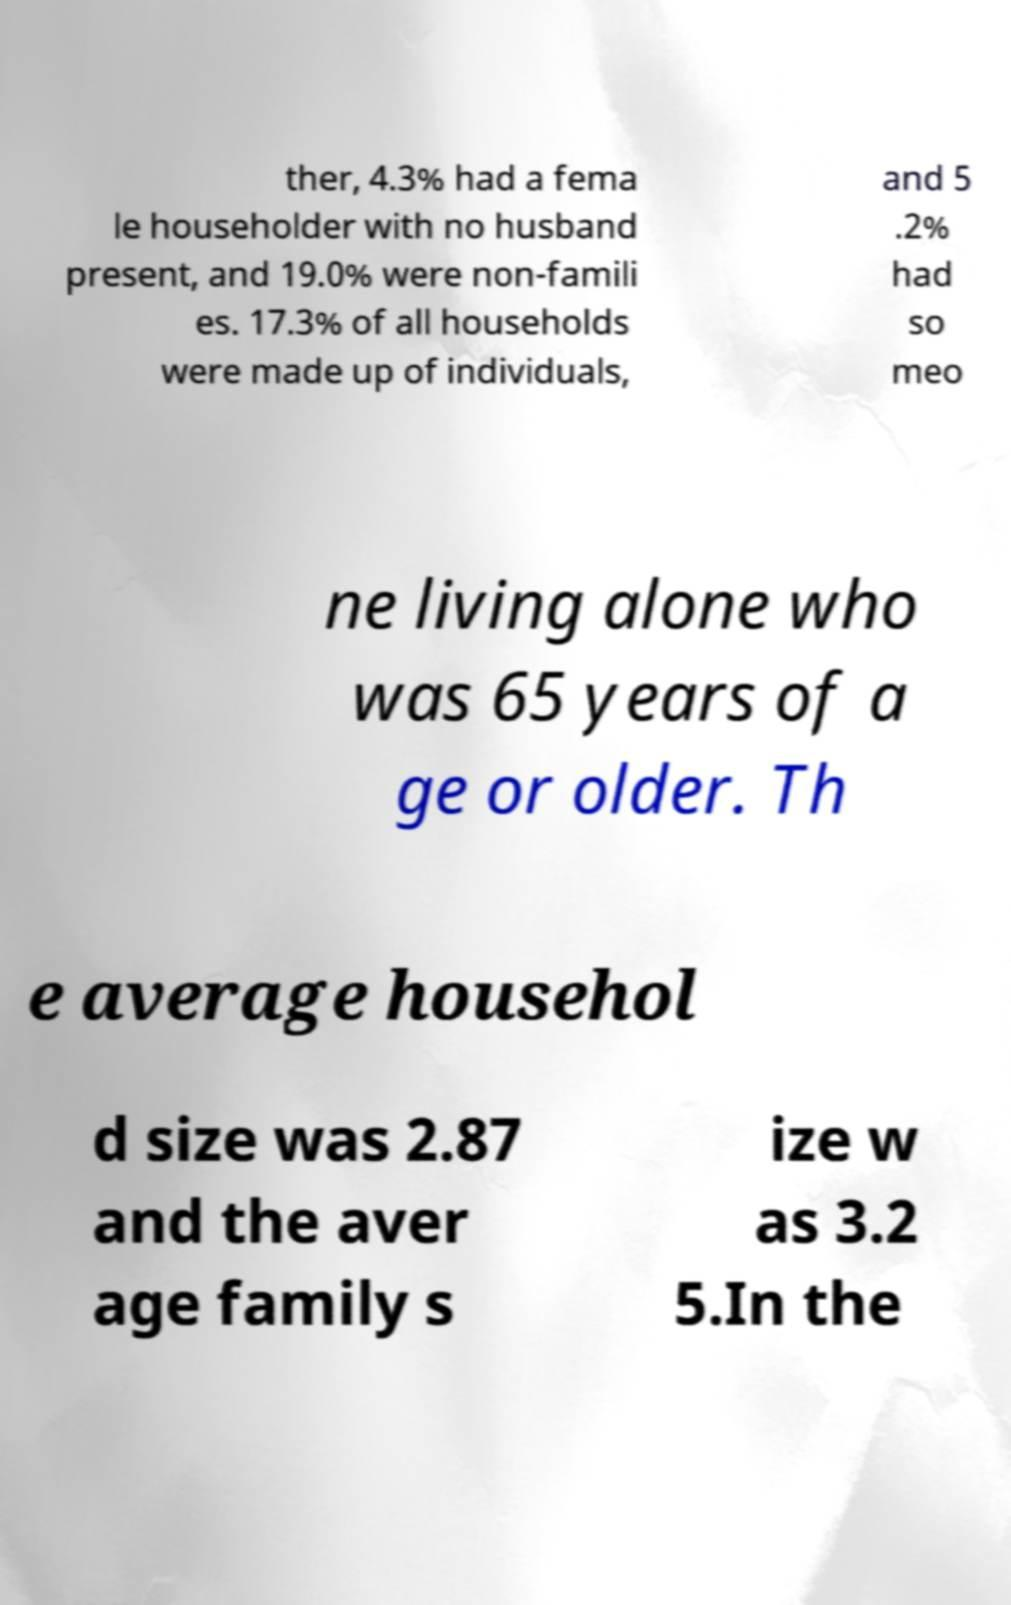Could you extract and type out the text from this image? ther, 4.3% had a fema le householder with no husband present, and 19.0% were non-famili es. 17.3% of all households were made up of individuals, and 5 .2% had so meo ne living alone who was 65 years of a ge or older. Th e average househol d size was 2.87 and the aver age family s ize w as 3.2 5.In the 